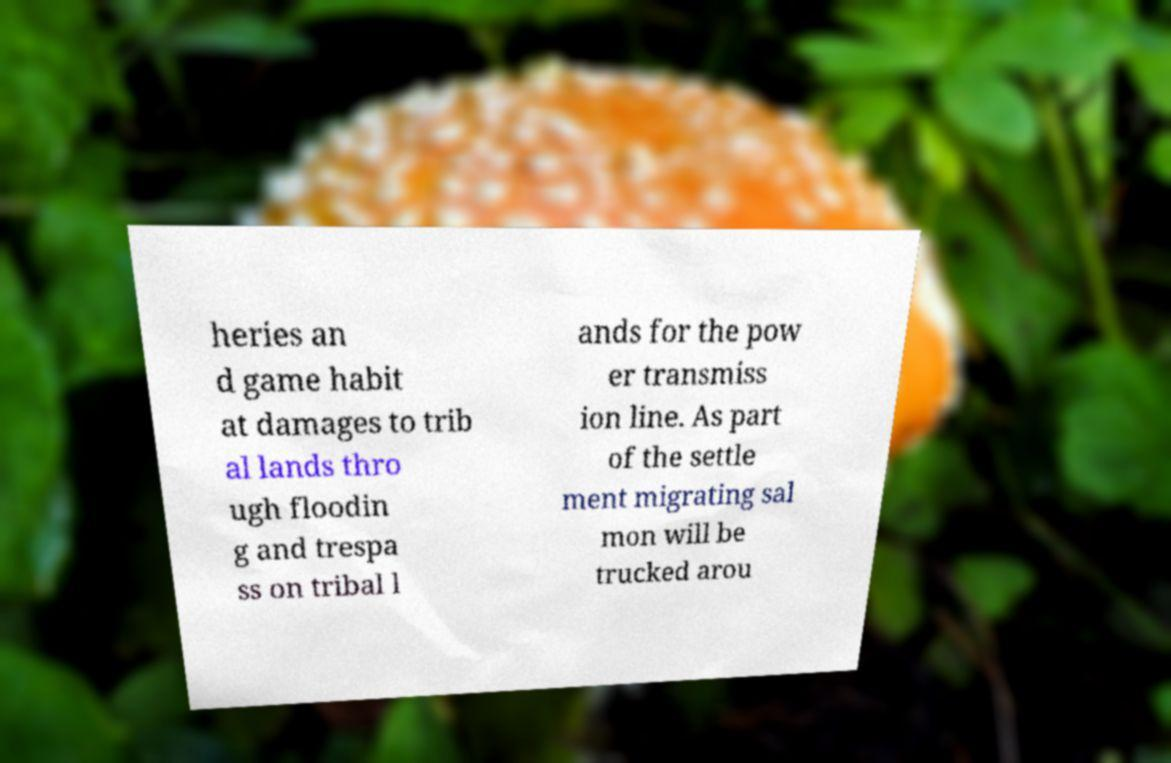I need the written content from this picture converted into text. Can you do that? heries an d game habit at damages to trib al lands thro ugh floodin g and trespa ss on tribal l ands for the pow er transmiss ion line. As part of the settle ment migrating sal mon will be trucked arou 